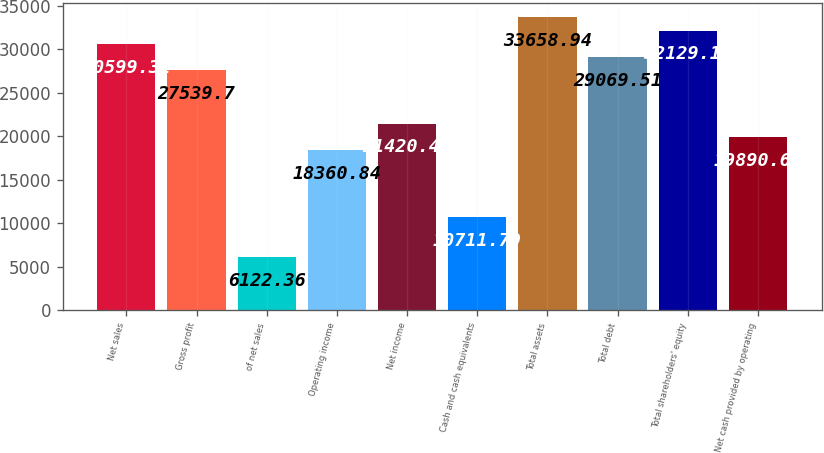Convert chart. <chart><loc_0><loc_0><loc_500><loc_500><bar_chart><fcel>Net sales<fcel>Gross profit<fcel>of net sales<fcel>Operating income<fcel>Net income<fcel>Cash and cash equivalents<fcel>Total assets<fcel>Total debt<fcel>Total shareholders' equity<fcel>Net cash provided by operating<nl><fcel>30599.3<fcel>27539.7<fcel>6122.36<fcel>18360.8<fcel>21420.5<fcel>10711.8<fcel>33658.9<fcel>29069.5<fcel>32129.1<fcel>19890.7<nl></chart> 